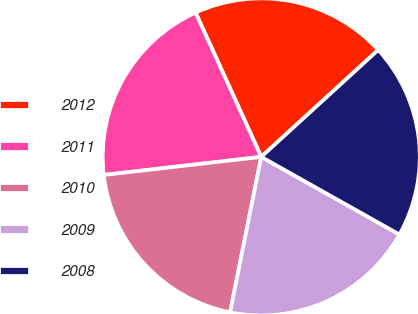<chart> <loc_0><loc_0><loc_500><loc_500><pie_chart><fcel>2012<fcel>2011<fcel>2010<fcel>2009<fcel>2008<nl><fcel>20.01%<fcel>20.02%<fcel>20.03%<fcel>20.0%<fcel>19.93%<nl></chart> 